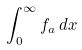Convert formula to latex. <formula><loc_0><loc_0><loc_500><loc_500>\int _ { 0 } ^ { \infty } f _ { a } \, d x</formula> 